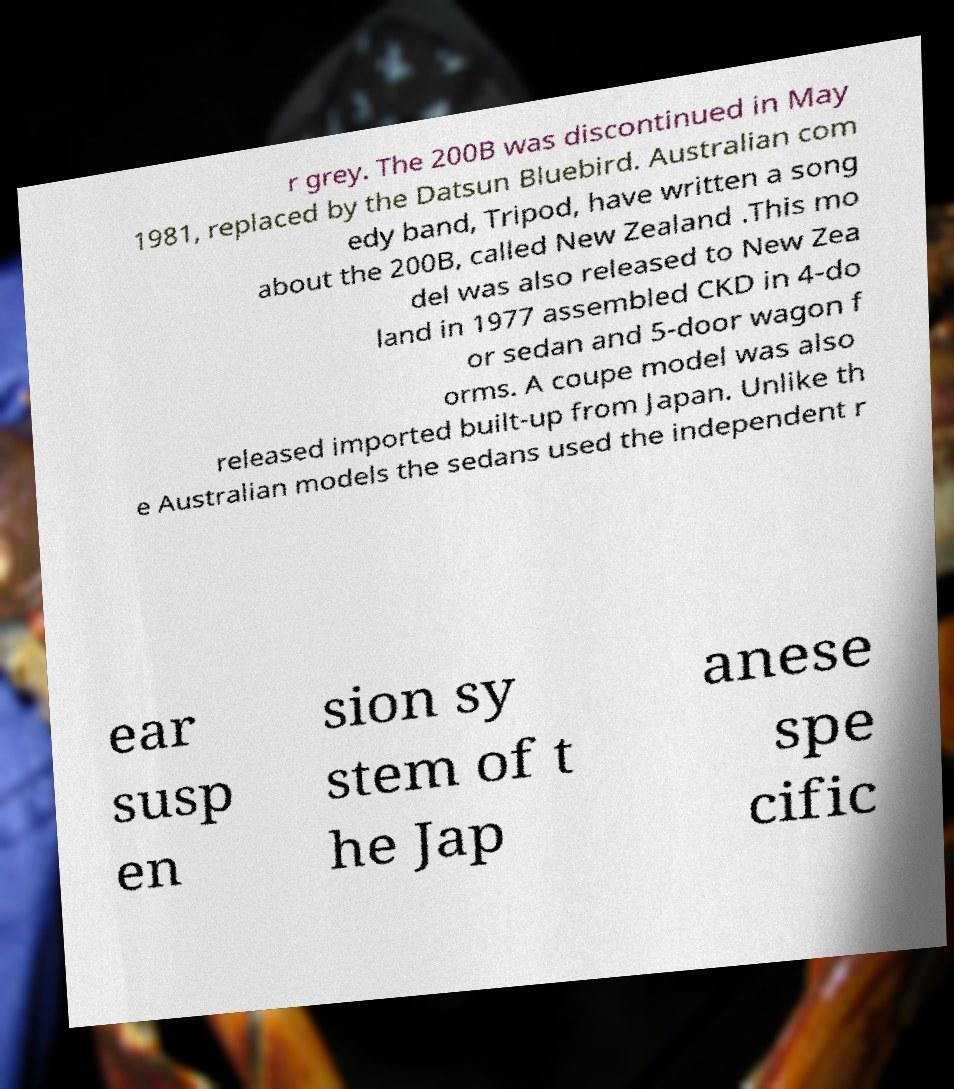There's text embedded in this image that I need extracted. Can you transcribe it verbatim? r grey. The 200B was discontinued in May 1981, replaced by the Datsun Bluebird. Australian com edy band, Tripod, have written a song about the 200B, called New Zealand .This mo del was also released to New Zea land in 1977 assembled CKD in 4-do or sedan and 5-door wagon f orms. A coupe model was also released imported built-up from Japan. Unlike th e Australian models the sedans used the independent r ear susp en sion sy stem of t he Jap anese spe cific 